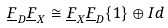<formula> <loc_0><loc_0><loc_500><loc_500>\underline { F } _ { D } \underline { F } _ { X } \cong \underline { F } _ { X } \underline { F } _ { D } \{ 1 \} \oplus I d</formula> 